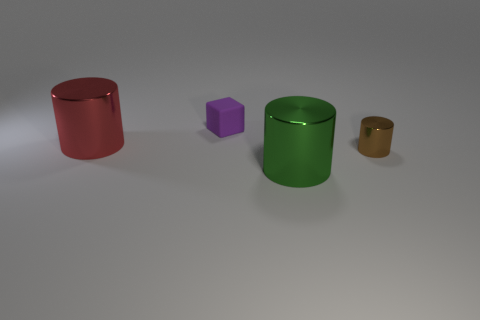Add 4 small purple rubber blocks. How many objects exist? 8 Subtract all cylinders. How many objects are left? 1 Subtract all big red things. Subtract all large gray matte balls. How many objects are left? 3 Add 4 matte objects. How many matte objects are left? 5 Add 3 cylinders. How many cylinders exist? 6 Subtract 0 green spheres. How many objects are left? 4 